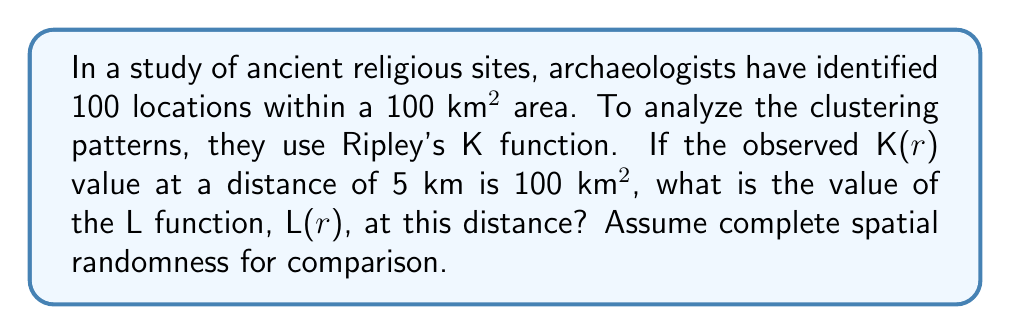Provide a solution to this math problem. To solve this problem, we'll follow these steps:

1) Recall the formula for Ripley's K function:
   $$K(r) = \frac{A}{n^2} \sum_{i=1}^n \sum_{j \neq i} I(d_{ij} < r)$$
   where A is the total area, n is the number of points, and I is an indicator function.

2) The L function is a variance-stabilized version of K(r), defined as:
   $$L(r) = \sqrt{\frac{K(r)}{\pi}} - r$$

3) We're given:
   - K(r) = 100 km² at r = 5 km
   - Total area A = 100 km²
   - Number of points n = 100

4) Substitute these values into the L function formula:
   $$L(r) = \sqrt{\frac{100}{\pi}} - 5$$

5) Simplify:
   $$L(r) = \sqrt{\frac{100}{\pi}} - 5 \approx 5.64 - 5 = 0.64$$

6) The positive L(r) value indicates clustering compared to complete spatial randomness.
Answer: 0.64 km 